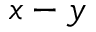<formula> <loc_0><loc_0><loc_500><loc_500>x - y</formula> 